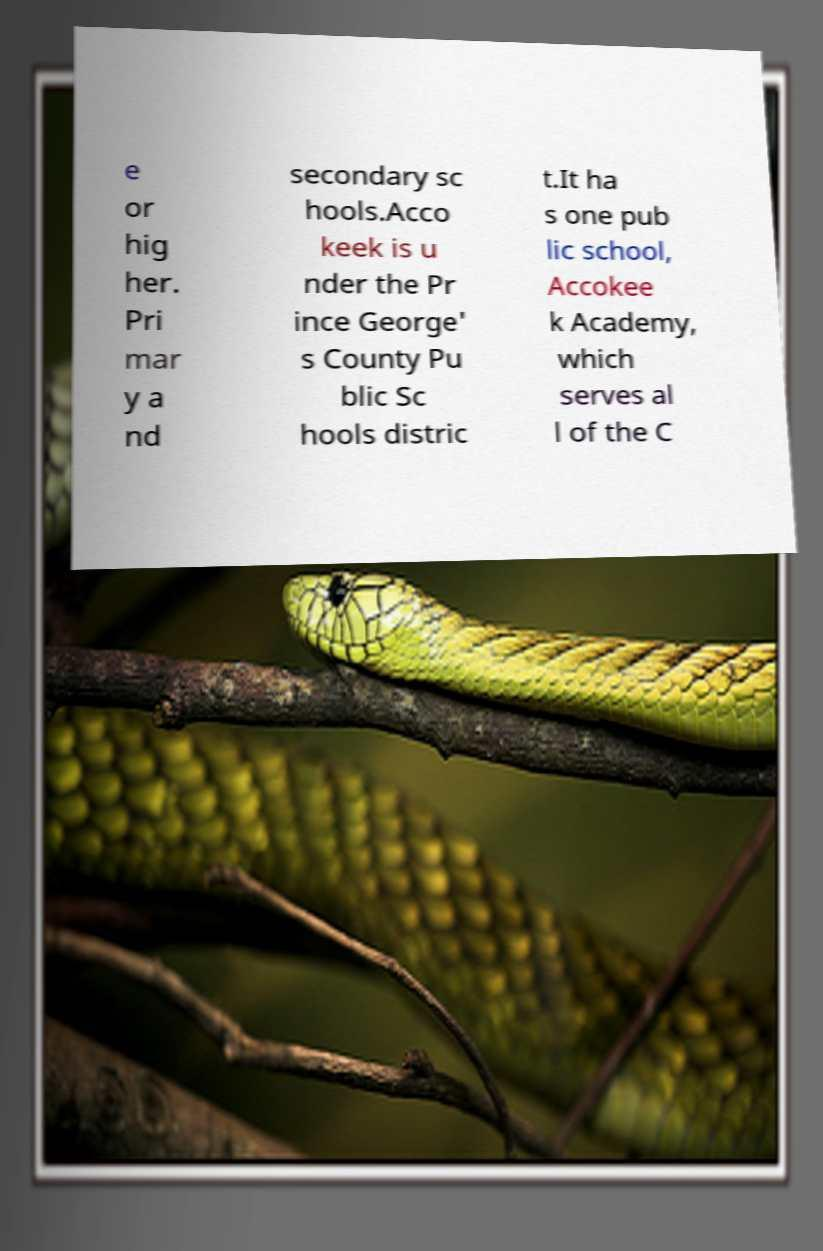Please read and relay the text visible in this image. What does it say? e or hig her. Pri mar y a nd secondary sc hools.Acco keek is u nder the Pr ince George' s County Pu blic Sc hools distric t.It ha s one pub lic school, Accokee k Academy, which serves al l of the C 